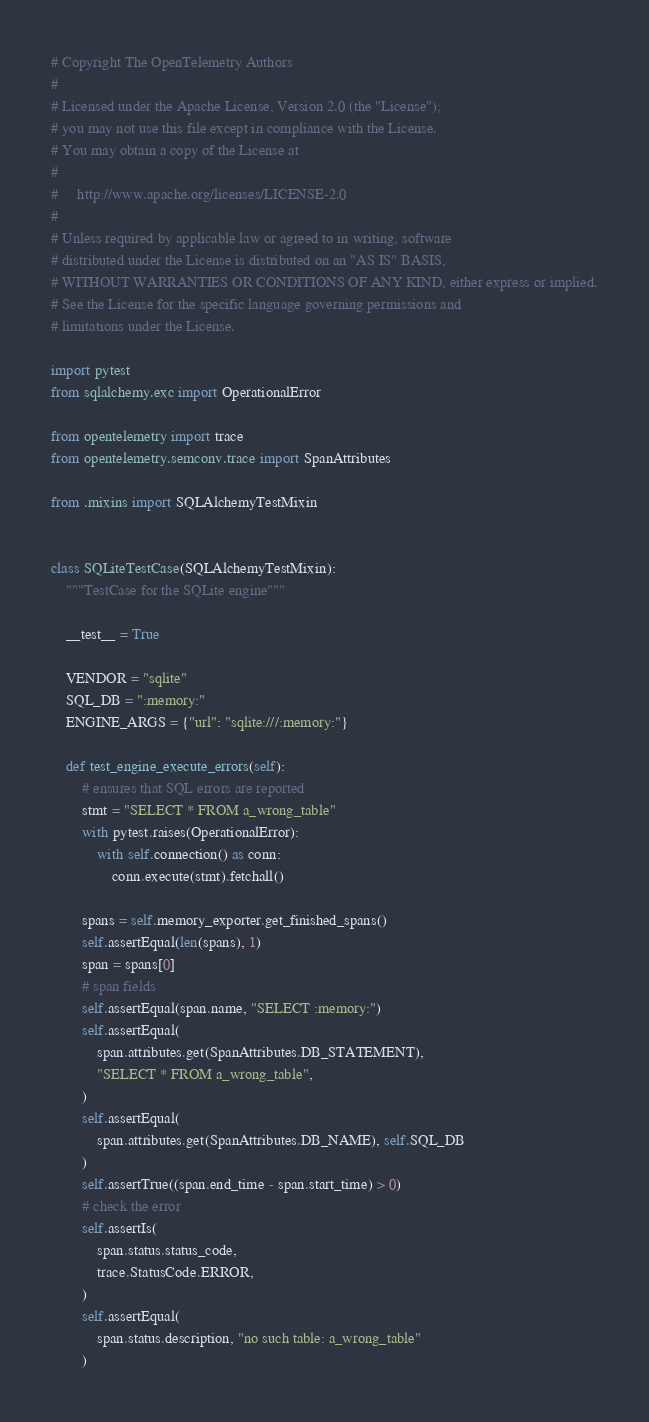<code> <loc_0><loc_0><loc_500><loc_500><_Python_># Copyright The OpenTelemetry Authors
#
# Licensed under the Apache License, Version 2.0 (the "License");
# you may not use this file except in compliance with the License.
# You may obtain a copy of the License at
#
#     http://www.apache.org/licenses/LICENSE-2.0
#
# Unless required by applicable law or agreed to in writing, software
# distributed under the License is distributed on an "AS IS" BASIS,
# WITHOUT WARRANTIES OR CONDITIONS OF ANY KIND, either express or implied.
# See the License for the specific language governing permissions and
# limitations under the License.

import pytest
from sqlalchemy.exc import OperationalError

from opentelemetry import trace
from opentelemetry.semconv.trace import SpanAttributes

from .mixins import SQLAlchemyTestMixin


class SQLiteTestCase(SQLAlchemyTestMixin):
    """TestCase for the SQLite engine"""

    __test__ = True

    VENDOR = "sqlite"
    SQL_DB = ":memory:"
    ENGINE_ARGS = {"url": "sqlite:///:memory:"}

    def test_engine_execute_errors(self):
        # ensures that SQL errors are reported
        stmt = "SELECT * FROM a_wrong_table"
        with pytest.raises(OperationalError):
            with self.connection() as conn:
                conn.execute(stmt).fetchall()

        spans = self.memory_exporter.get_finished_spans()
        self.assertEqual(len(spans), 1)
        span = spans[0]
        # span fields
        self.assertEqual(span.name, "SELECT :memory:")
        self.assertEqual(
            span.attributes.get(SpanAttributes.DB_STATEMENT),
            "SELECT * FROM a_wrong_table",
        )
        self.assertEqual(
            span.attributes.get(SpanAttributes.DB_NAME), self.SQL_DB
        )
        self.assertTrue((span.end_time - span.start_time) > 0)
        # check the error
        self.assertIs(
            span.status.status_code,
            trace.StatusCode.ERROR,
        )
        self.assertEqual(
            span.status.description, "no such table: a_wrong_table"
        )
</code> 